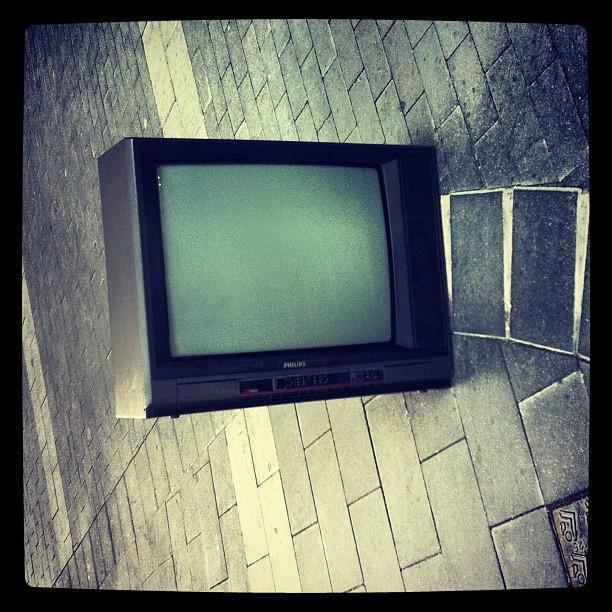How many people are wearing pink hats?
Give a very brief answer. 0. 